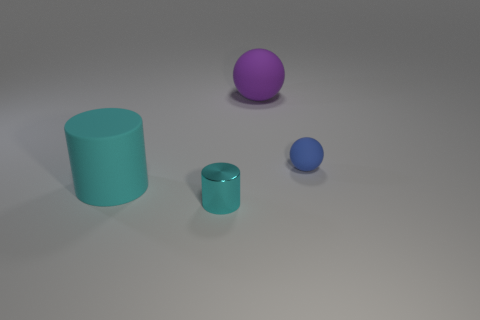Add 2 tiny cyan shiny things. How many objects exist? 6 Subtract all cylinders. Subtract all tiny metal objects. How many objects are left? 1 Add 1 blue spheres. How many blue spheres are left? 2 Add 4 yellow blocks. How many yellow blocks exist? 4 Subtract 0 yellow balls. How many objects are left? 4 